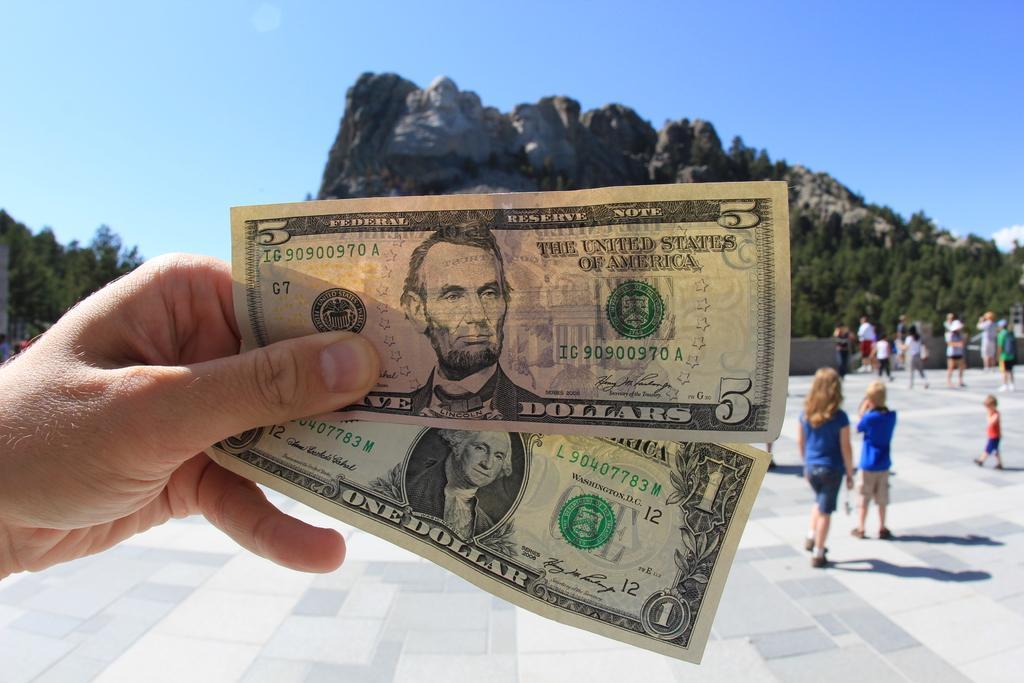Could you give a brief overview of what you see in this image? In this image we can see a few people and one person is holding a dollar bill, in the background there are mountains, trees and sky. 